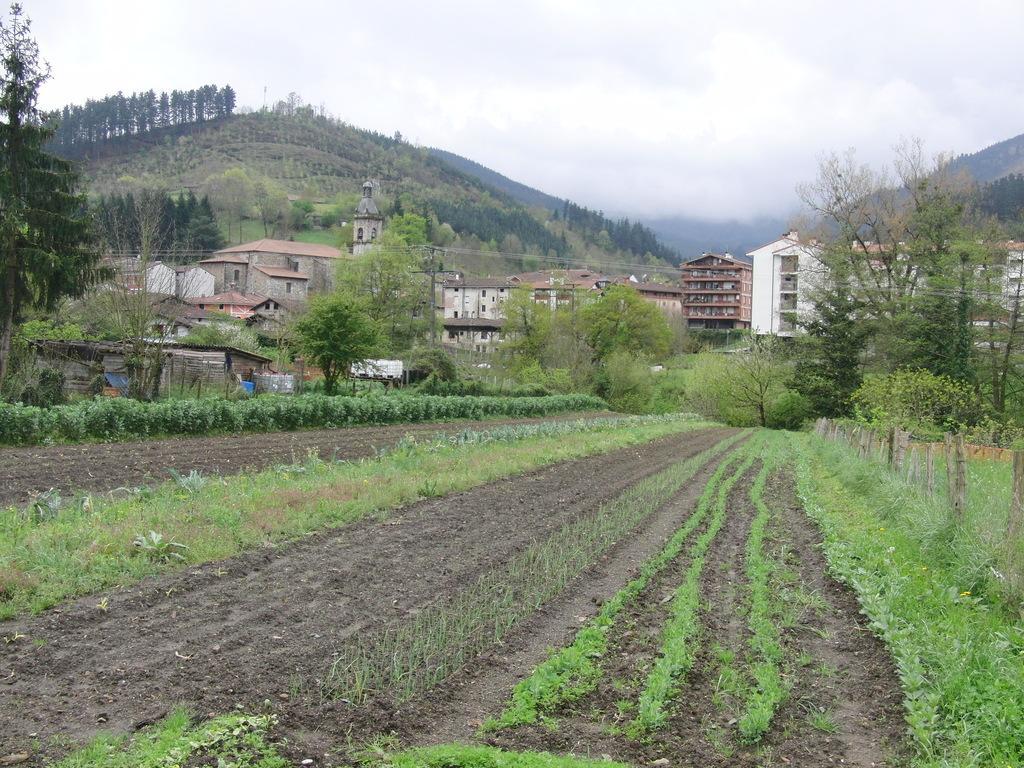In one or two sentences, can you explain what this image depicts? In this image, we can see fields and in the background, there are hills, trees, buildings and there is a tower. 